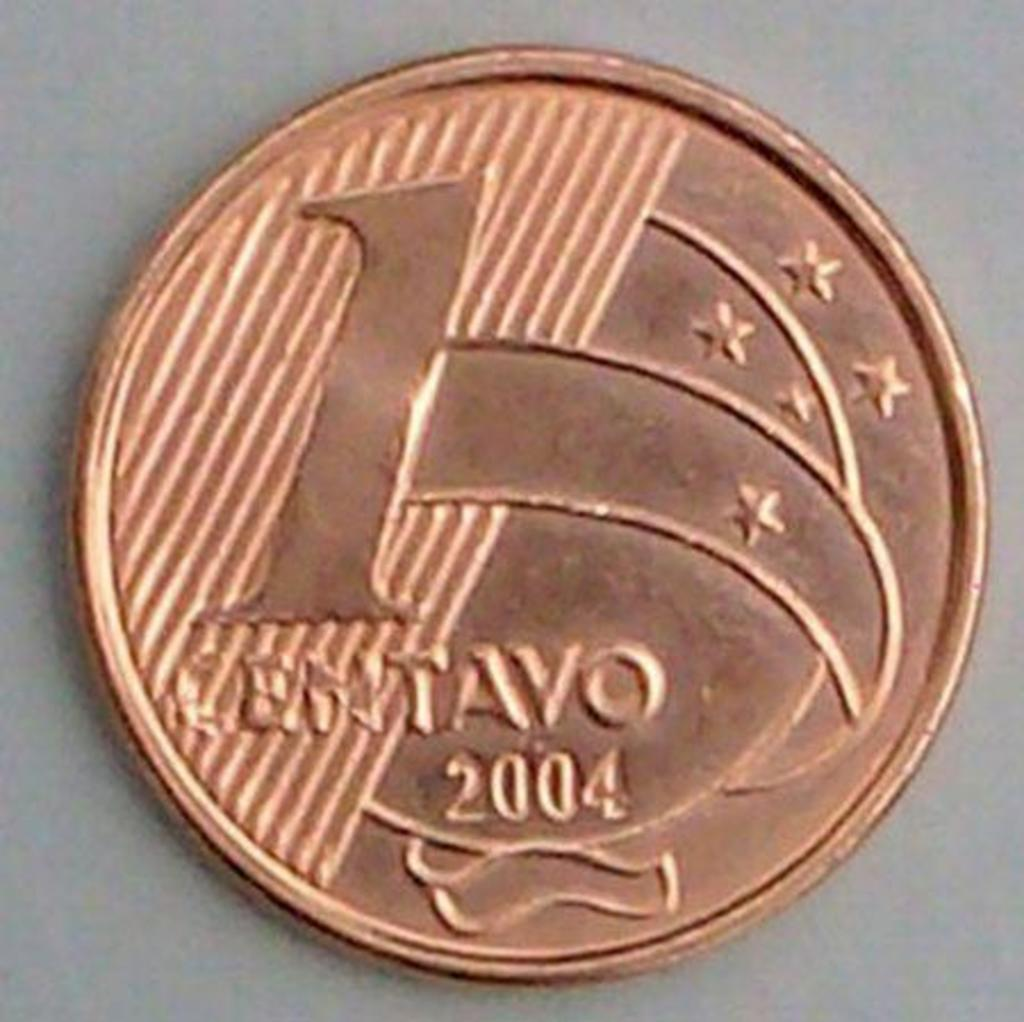<image>
Summarize the visual content of the image. A one centavo coin was made in 2004. 